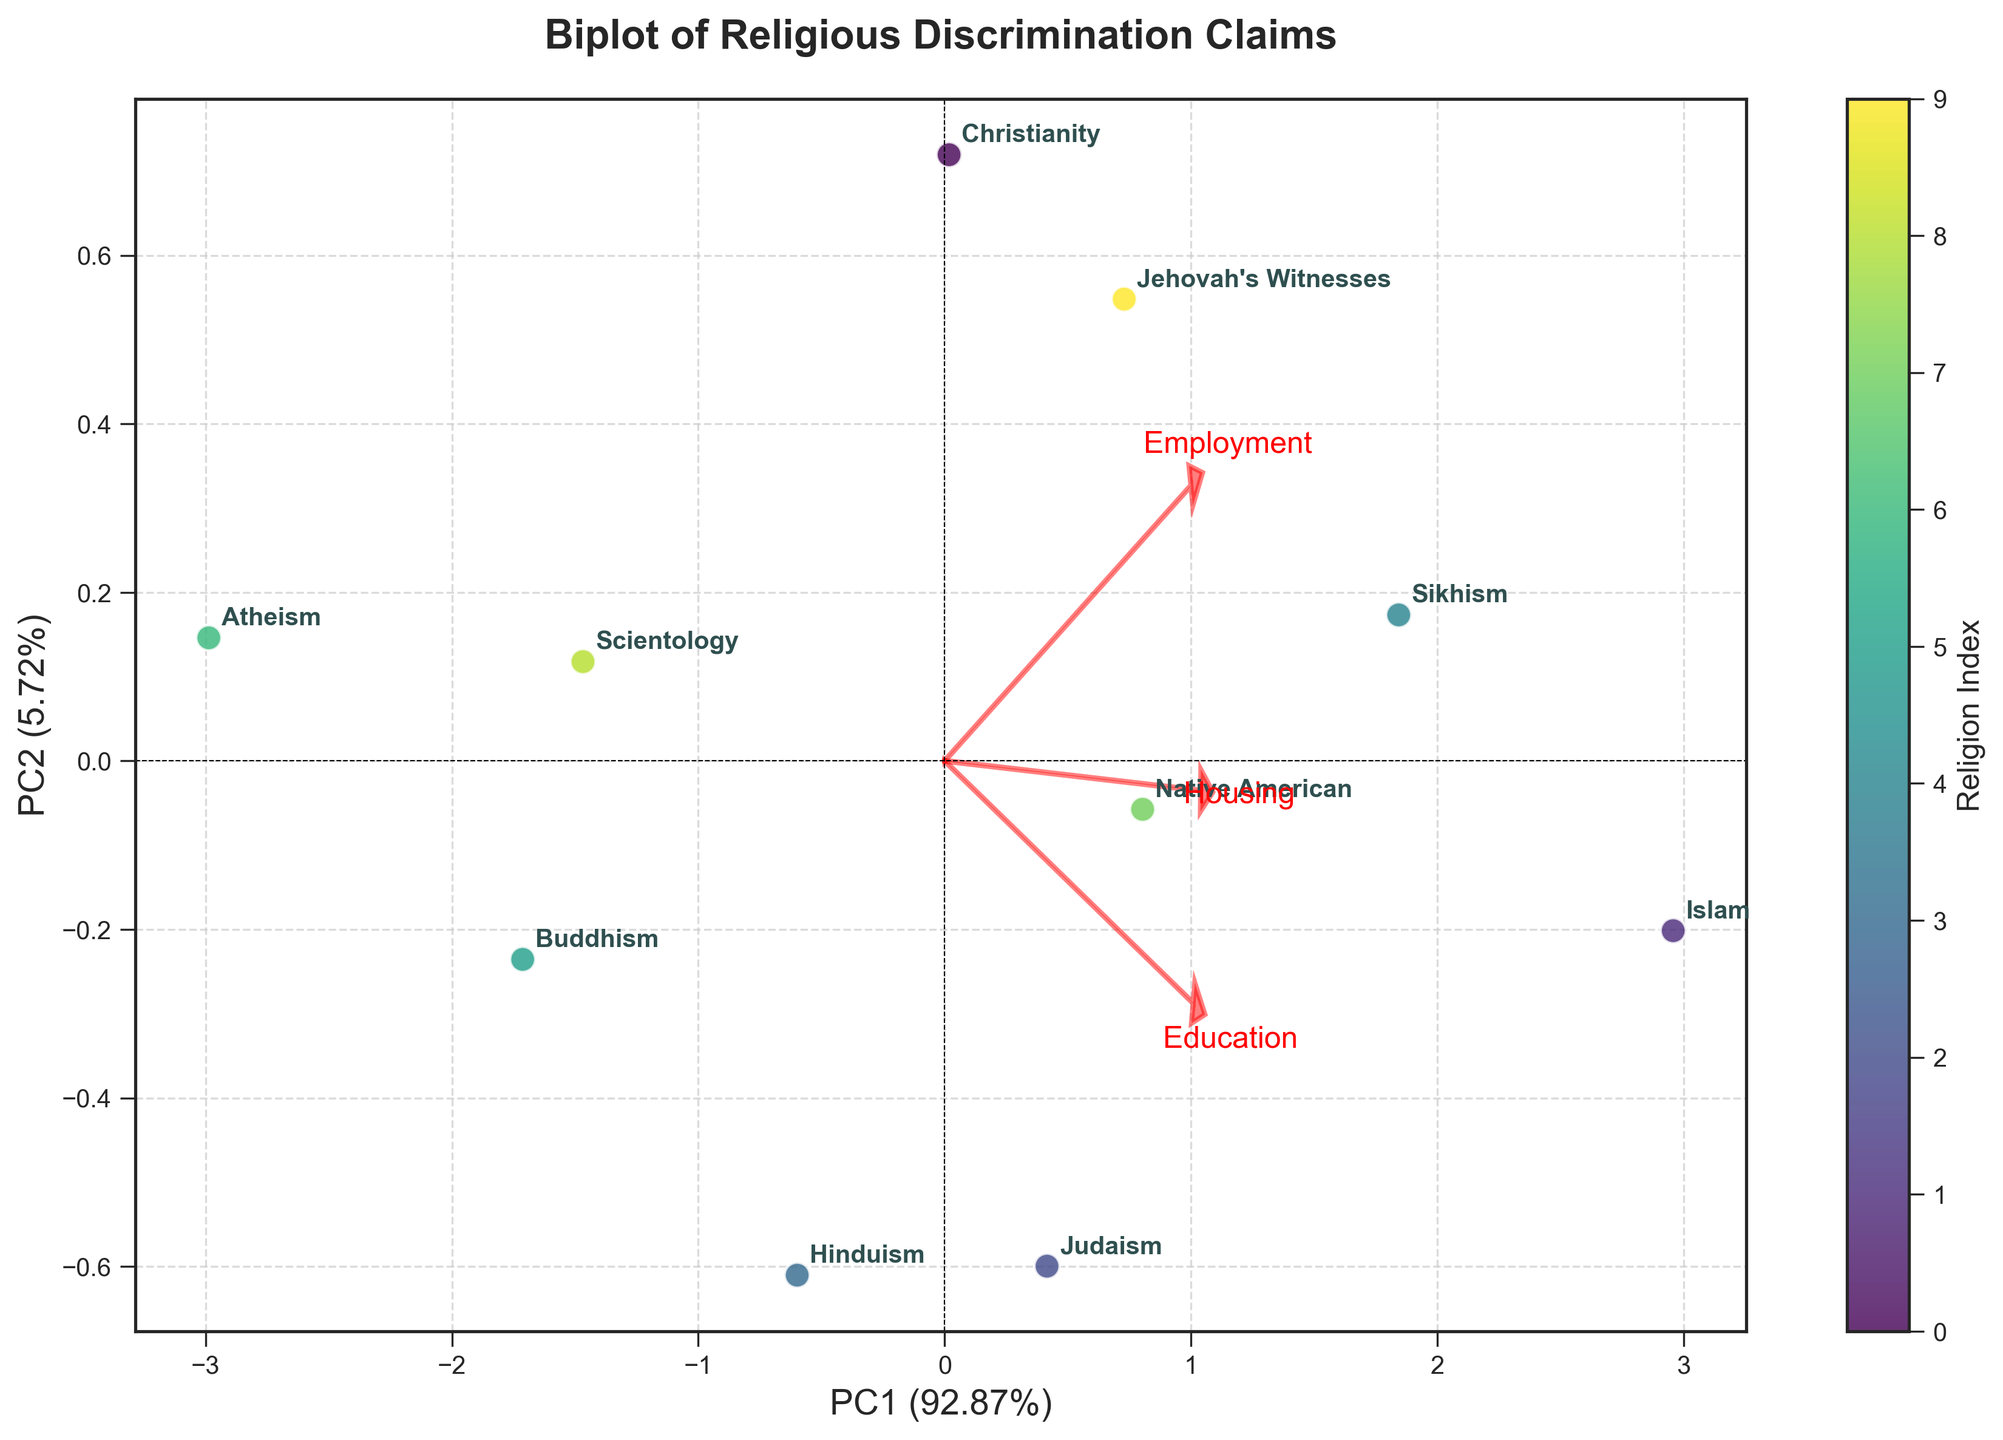What is the title of the plot? The title of the plot is typically found at the top center of the figure and describes what the plot represents.
Answer: Biplot of Religious Discrimination Claims How many religions are represented in the plot? Each data point in the plot likely represents a different religion, and there are annotations labeling each religion. Counting these annotations will give the total number of religions.
Answer: 10 Which type of discrimination claim (employment, housing, education) has the highest variance captured by PC1? The direction of the loading arrows from the origin indicates the contribution of each type of discrimination claim to PC1. The longer the arrow in the horizontal (PC1) direction, the higher the variance captured by PC1.
Answer: Employment Which two religions have the most similar positions in the PCA plot? Look for two points that are closest to each other on the plot, indicating they have very similar PCA scores.
Answer: Judaism and Native American How does Islam compare to Christianity in terms of PC1 score? Find the positions of Islam and Christianity along the horizontal axis (PC1) and compare which one is further to the right (higher PC1 score) or to the left (lower PC1 score).
Answer: Islam has a higher PC1 score than Christianity What variables are most strongly correlated with each other? The directions and lengths of the loading arrows indicate correlations. Arrows that point in the same direction and are of similar length represent strongly correlated variables.
Answer: Housing and Education What is the position of Scientology relative to the origin on the PC2 axis? Identify the position of Scientology and then determine whether it is above or below the horizontal axis (PC2), as well as how far it is from the origin.
Answer: Below the origin on PC2 What is the range of the PC1 values for all the religions? Identify the maximum and minimum PC1 values represented by the plotted points and calculate the range as the difference between them.
Answer: Range is from approximately -2 to 2 What can be inferred about the relationship between Employment discrimination and Housing discrimination? Look at the angles between the arrows for Employment and Housing. If the arrows point in similar directions, the relationship is positively correlated; opposite directions indicate a negative correlation.
Answer: There is a positive correlation What is the PCA explained variance ratio for PC1? The explained variance ratio for PC1 is typically labeled on the axis as a percentage. It shows the proportion of the total variance that is explained by PC1.
Answer: About 45% 